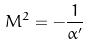Convert formula to latex. <formula><loc_0><loc_0><loc_500><loc_500>M ^ { 2 } = - \frac { 1 } { \alpha ^ { \prime } }</formula> 